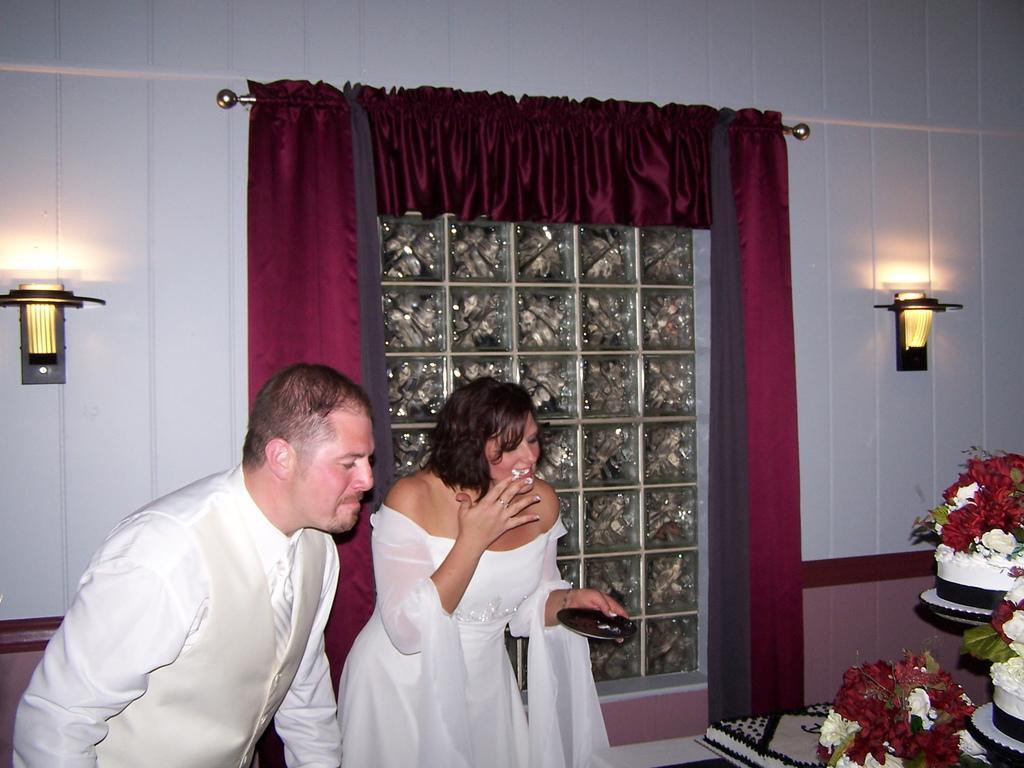How would you summarize this image in a sentence or two? There is a man and woman. Woman is holding a plate. On the right side there are cakes. Near to that there are flowers. In the background there is a wall with a window and curtains. On the wall there are lights. 